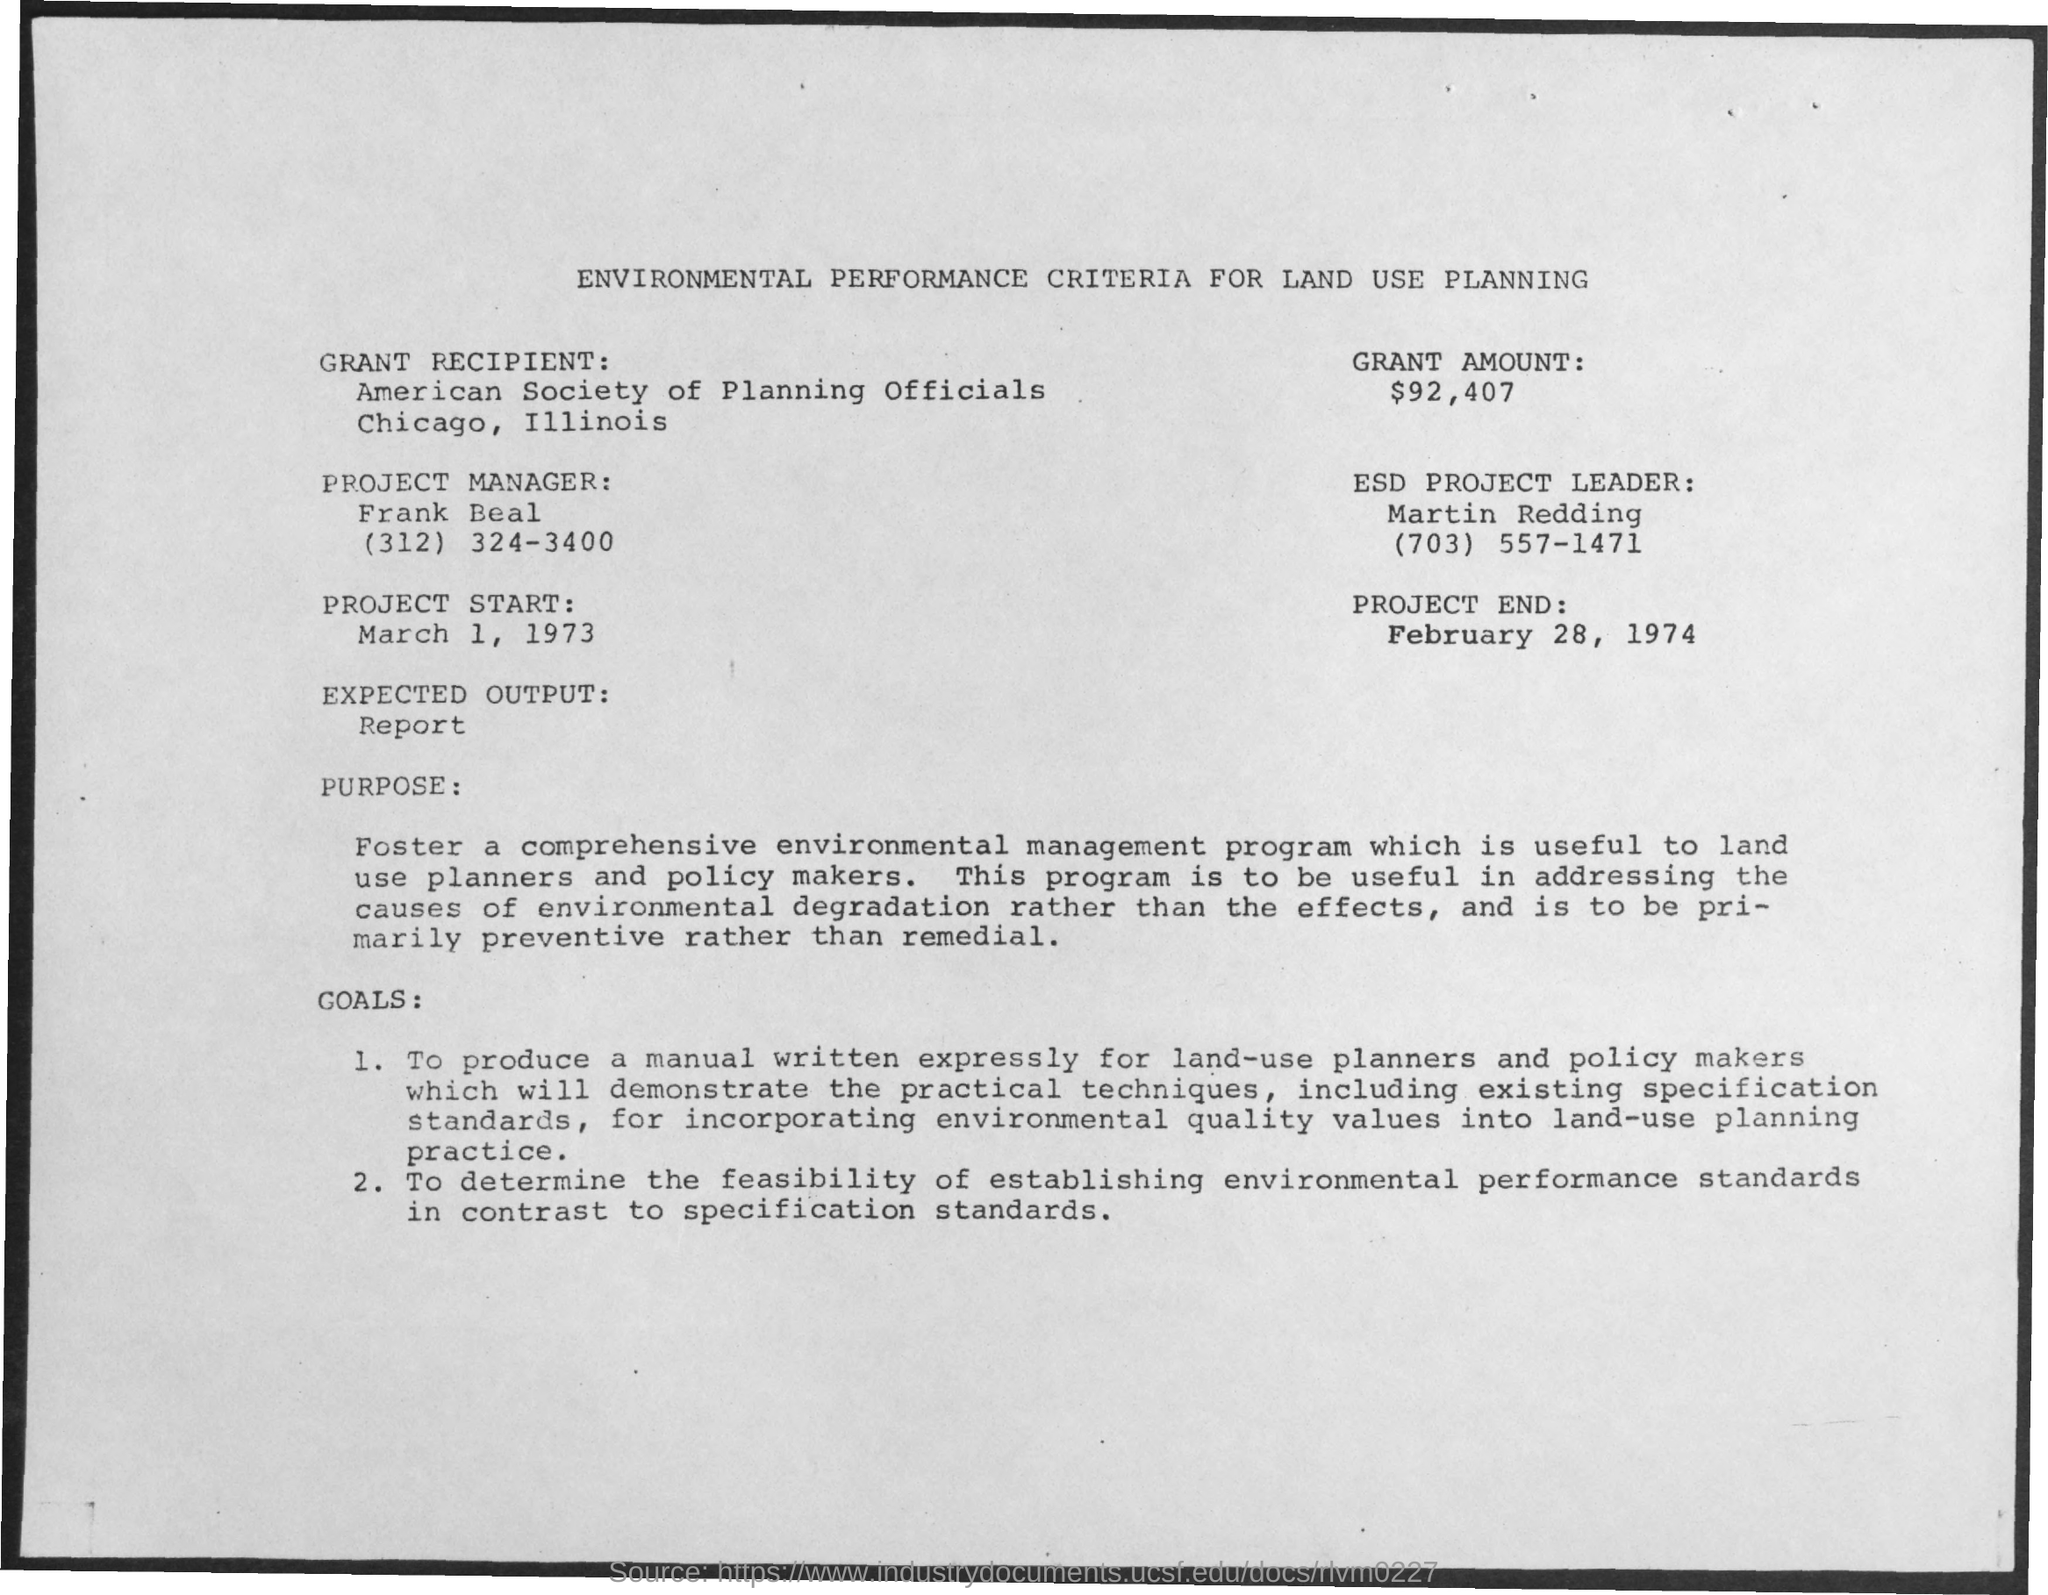Draw attention to some important aspects in this diagram. According to the document, Martin Redding is the ESD Project Leader. The project end date mentioned in the document is February 28, 1974. The grant amount mentioned in the document is $92,407. The project start date mentioned in the document is March 1, 1973. Frank Beal is the project manager as mentioned in the document. 